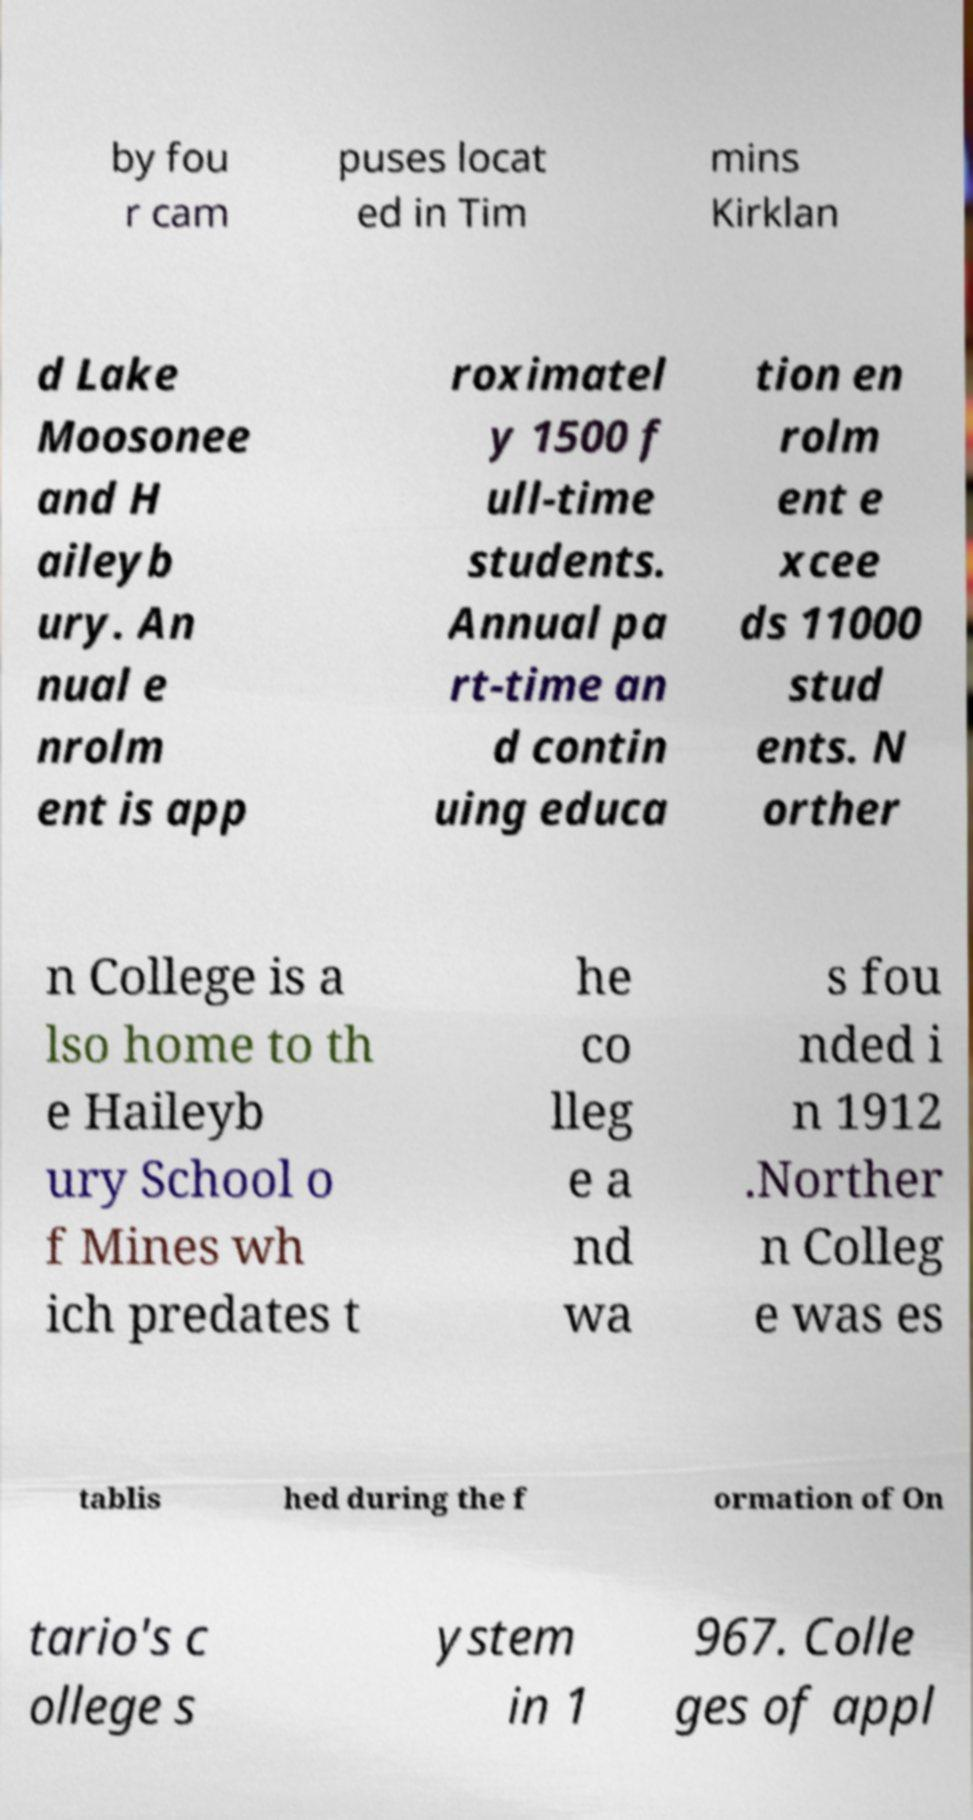Please read and relay the text visible in this image. What does it say? by fou r cam puses locat ed in Tim mins Kirklan d Lake Moosonee and H aileyb ury. An nual e nrolm ent is app roximatel y 1500 f ull-time students. Annual pa rt-time an d contin uing educa tion en rolm ent e xcee ds 11000 stud ents. N orther n College is a lso home to th e Haileyb ury School o f Mines wh ich predates t he co lleg e a nd wa s fou nded i n 1912 .Norther n Colleg e was es tablis hed during the f ormation of On tario's c ollege s ystem in 1 967. Colle ges of appl 